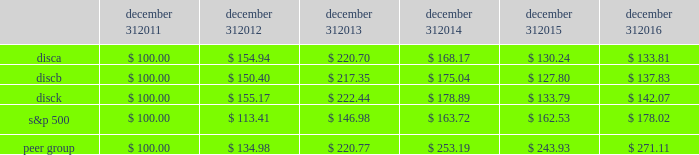December 31 , december 31 , december 31 , december 31 , december 31 , december 31 .
Equity compensation plan information information regarding securities authorized for issuance under equity compensation plans will be set forth in our definitive proxy statement for our 2017 annual meeting of stockholders under the caption 201csecurities authorized for issuance under equity compensation plans , 201d which is incorporated herein by reference .
Item 6 .
Selected financial data .
The table set forth below presents our selected financial information for each of the past five years ( in millions , except per share amounts ) .
The selected statement of operations information for each of the three years ended december 31 , 2016 and the selected balance sheet information as of december 31 , 2016 and 2015 have been derived from and should be read in conjunction with the information in item 7 , 201cmanagement 2019s discussion and analysis of financial condition and results of operations , 201d the audited consolidated financial statements included in item 8 , 201cfinancial statements and supplementary data , 201d and other financial information included elsewhere in this annual report on form 10-k .
The selected statement of operations information for each of the two years ended december 31 , 2013 and 2012 and the selected balance sheet information as of december 31 , 2014 , 2013 and 2012 have been derived from financial statements not included in this annual report on form 10-k .
2016 2015 2014 2013 2012 selected statement of operations information : revenues $ 6497 $ 6394 $ 6265 $ 5535 $ 4487 operating income 2058 1985 2061 1975 1859 income from continuing operations , net of taxes 1218 1048 1137 1077 956 loss from discontinued operations , net of taxes 2014 2014 2014 2014 ( 11 ) net income 1218 1048 1137 1077 945 net income available to discovery communications , inc .
1194 1034 1139 1075 943 basic earnings per share available to discovery communications , inc .
Series a , b and c common stockholders : continuing operations $ 1.97 $ 1.59 $ 1.67 $ 1.50 $ 1.27 discontinued operations 2014 2014 2014 2014 ( 0.01 ) net income 1.97 1.59 1.67 1.50 1.25 diluted earnings per share available to discovery communications , inc .
Series a , b and c common stockholders : continuing operations $ 1.96 $ 1.58 $ 1.66 $ 1.49 $ 1.26 discontinued operations 2014 2014 2014 2014 ( 0.01 ) net income 1.96 1.58 1.66 1.49 1.24 weighted average shares outstanding : basic 401 432 454 484 498 diluted 610 656 687 722 759 selected balance sheet information : cash and cash equivalents $ 300 $ 390 $ 367 $ 408 $ 1201 total assets 15758 15864 15970 14934 12892 long-term debt : current portion 82 119 1107 17 31 long-term portion 7841 7616 6002 6437 5174 total liabilities 10348 10172 9619 8701 6599 redeemable noncontrolling interests 243 241 747 36 2014 equity attributable to discovery communications , inc .
5167 5451 5602 6196 6291 total equity $ 5167 $ 5451 $ 5604 $ 6197 $ 6293 2022 income per share amounts may not sum since each is calculated independently .
2022 on september 30 , 2016 , the company recorded an other-than-temporary impairment of $ 62 million related to its investment in lionsgate .
On december 2 , 2016 , the company acquired a 39% ( 39 % ) minority interest in group nine media , a newly formed media holding company , in exchange for contributions of $ 100 million and the company's digital network businesses seeker and sourcefed , resulting in a gain of $ 50 million upon deconsolidation of the businesses .
( see note 4 to the accompanying consolidated financial statements. ) .
What was the 5 year total return on the b stock? 
Computations: (137.83 - 100.00)
Answer: 37.83. 